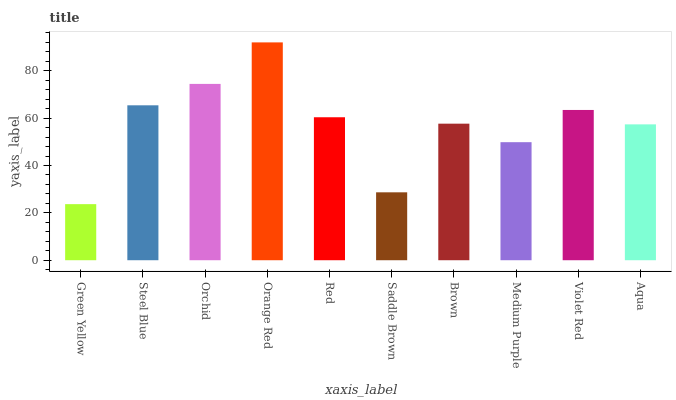Is Green Yellow the minimum?
Answer yes or no. Yes. Is Orange Red the maximum?
Answer yes or no. Yes. Is Steel Blue the minimum?
Answer yes or no. No. Is Steel Blue the maximum?
Answer yes or no. No. Is Steel Blue greater than Green Yellow?
Answer yes or no. Yes. Is Green Yellow less than Steel Blue?
Answer yes or no. Yes. Is Green Yellow greater than Steel Blue?
Answer yes or no. No. Is Steel Blue less than Green Yellow?
Answer yes or no. No. Is Red the high median?
Answer yes or no. Yes. Is Brown the low median?
Answer yes or no. Yes. Is Violet Red the high median?
Answer yes or no. No. Is Medium Purple the low median?
Answer yes or no. No. 